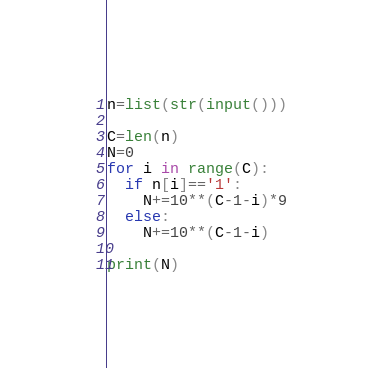Convert code to text. <code><loc_0><loc_0><loc_500><loc_500><_Python_>n=list(str(input()))

C=len(n)
N=0
for i in range(C):
  if n[i]=='1':
    N+=10**(C-1-i)*9
  else:
    N+=10**(C-1-i)

print(N)  </code> 